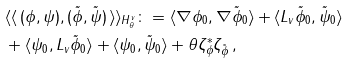Convert formula to latex. <formula><loc_0><loc_0><loc_500><loc_500>& \langle \langle \, ( \phi , \psi ) , ( \tilde { \phi } , \tilde { \psi } ) \, \rangle \rangle _ { H ^ { v } _ { \theta } } \colon = \langle \nabla \phi _ { 0 } , \nabla \tilde { \phi } _ { 0 } \rangle + \langle L _ { v } \tilde { \phi } _ { 0 } , \tilde { \psi } _ { 0 } \rangle \\ & + \langle \psi _ { 0 } , L _ { v } \tilde { \phi } _ { 0 } \rangle + \langle \psi _ { 0 } , \tilde { \psi } _ { 0 } \rangle + \theta \zeta _ { \phi } ^ { * } \zeta _ { \tilde { \phi } } \, ,</formula> 